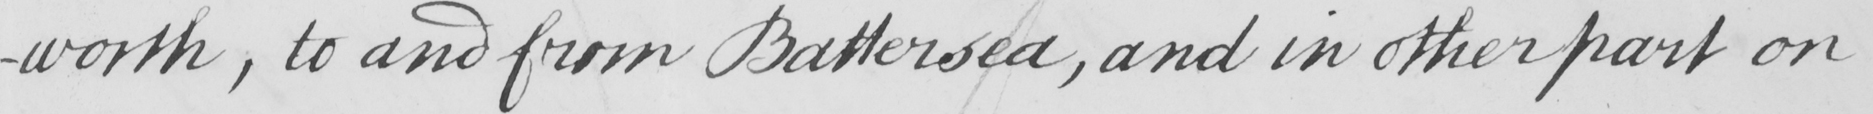Can you read and transcribe this handwriting? -worth , to and from Battersea , and in other part on 